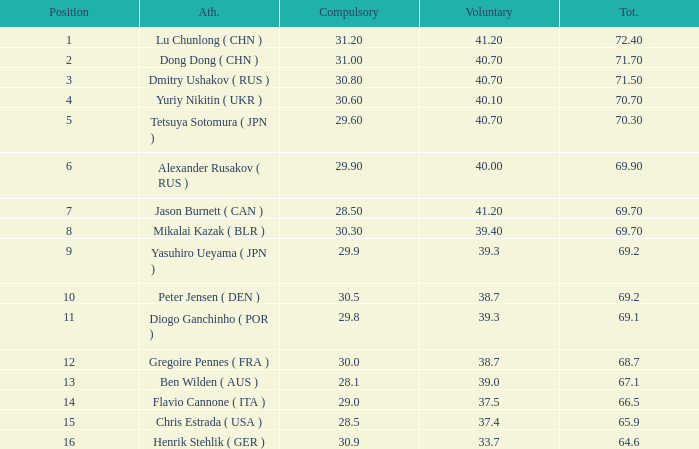What's the total compulsory when the total is more than 69.2 and the voluntary is 38.7? 0.0. 